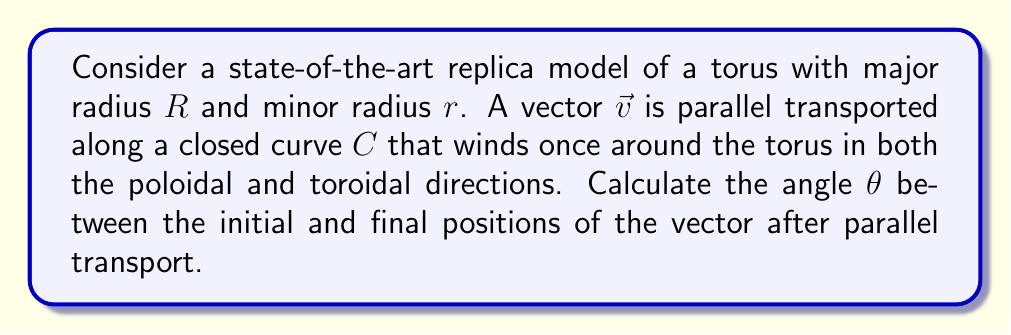Teach me how to tackle this problem. Let's approach this step-by-step:

1) The parallel transport of a vector on a curved surface can result in a rotation of the vector when it returns to its starting point. This rotation is related to the Gaussian curvature of the surface enclosed by the path.

2) For a torus, the Gaussian curvature $K$ at any point is given by:

   $$K = \frac{\cos\phi}{r(R + r\cos\phi)}$$

   where $\phi$ is the angle in the poloidal direction.

3) The total rotation angle $\theta$ is given by the integral of the Gaussian curvature over the area enclosed by the path:

   $$\theta = \iint_A K \, dA$$

4) For a path that winds once around both directions of the torus, the enclosed area is the entire surface area of the torus.

5) We can parameterize the torus surface with angles $\phi$ (poloidal) and $\psi$ (toroidal):

   $$x = (R + r\cos\phi)\cos\psi$$
   $$y = (R + r\cos\phi)\sin\psi$$
   $$z = r\sin\phi$$

6) The area element is:

   $$dA = r(R + r\cos\phi) \, d\phi \, d\psi$$

7) Now we can set up the integral:

   $$\theta = \int_0^{2\pi}\int_0^{2\pi} \frac{\cos\phi}{r(R + r\cos\phi)} \cdot r(R + r\cos\phi) \, d\phi \, d\psi$$

8) Simplifying:

   $$\theta = \int_0^{2\pi}\int_0^{2\pi} \cos\phi \, d\phi \, d\psi$$

9) Evaluating the integral:

   $$\theta = 2\pi \cdot [\sin\phi]_0^{2\pi} = 2\pi \cdot 0 = 0$$

Therefore, the vector returns to its original orientation after parallel transport around this closed curve on the torus.
Answer: $\theta = 0$ 